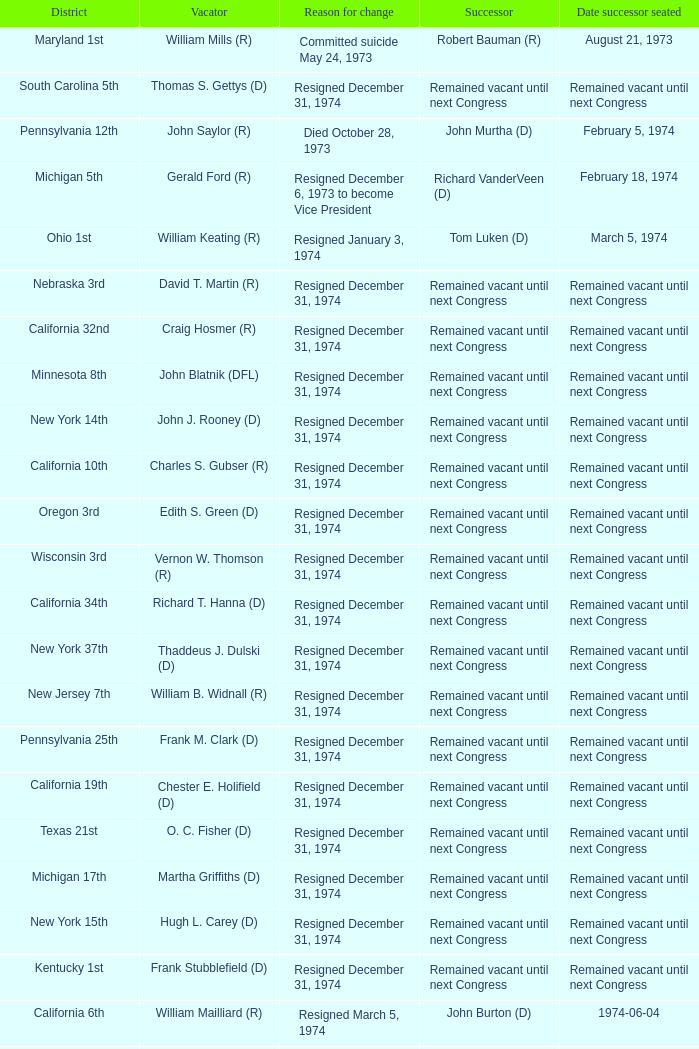When was the date successor seated when the vacator was charles e. chamberlain (r)? Remained vacant until next Congress. 